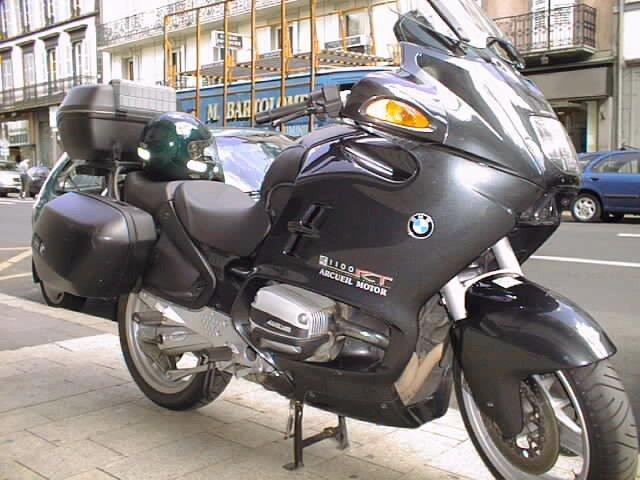How many cars are there?
Give a very brief answer. 2. 